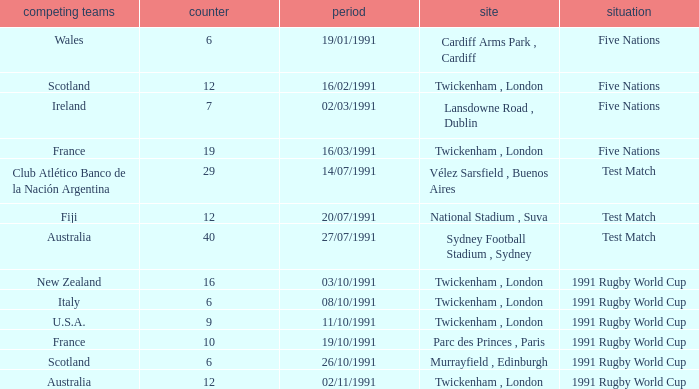What is Against, when Opposing Teams is "Australia", and when Date is "27/07/1991"? 40.0. 